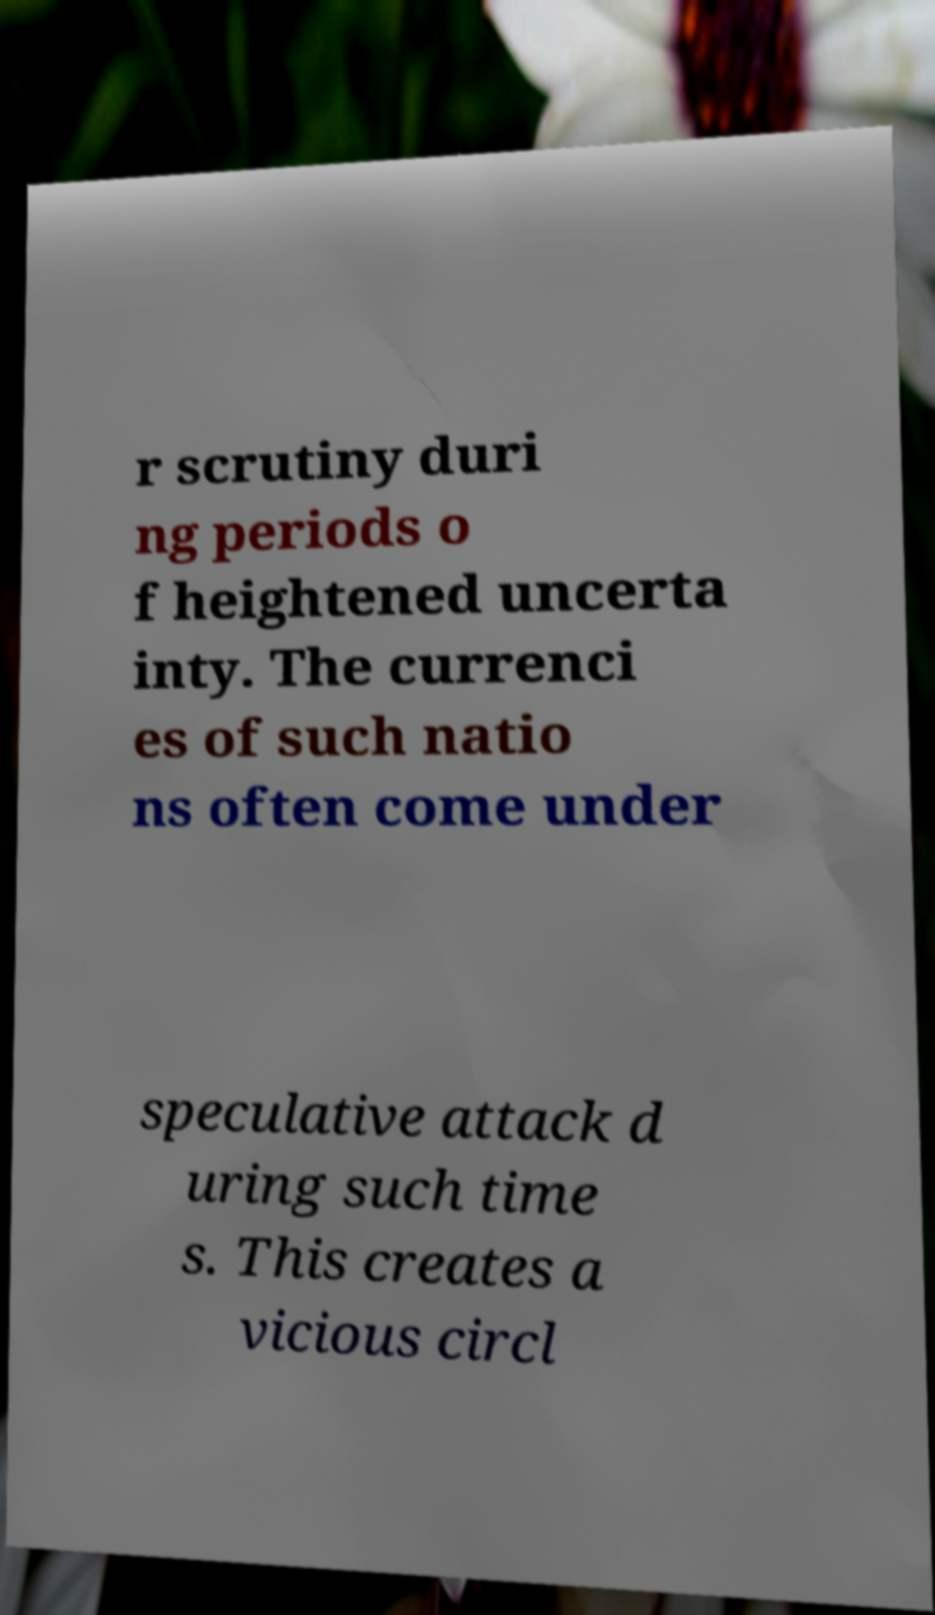Please read and relay the text visible in this image. What does it say? r scrutiny duri ng periods o f heightened uncerta inty. The currenci es of such natio ns often come under speculative attack d uring such time s. This creates a vicious circl 